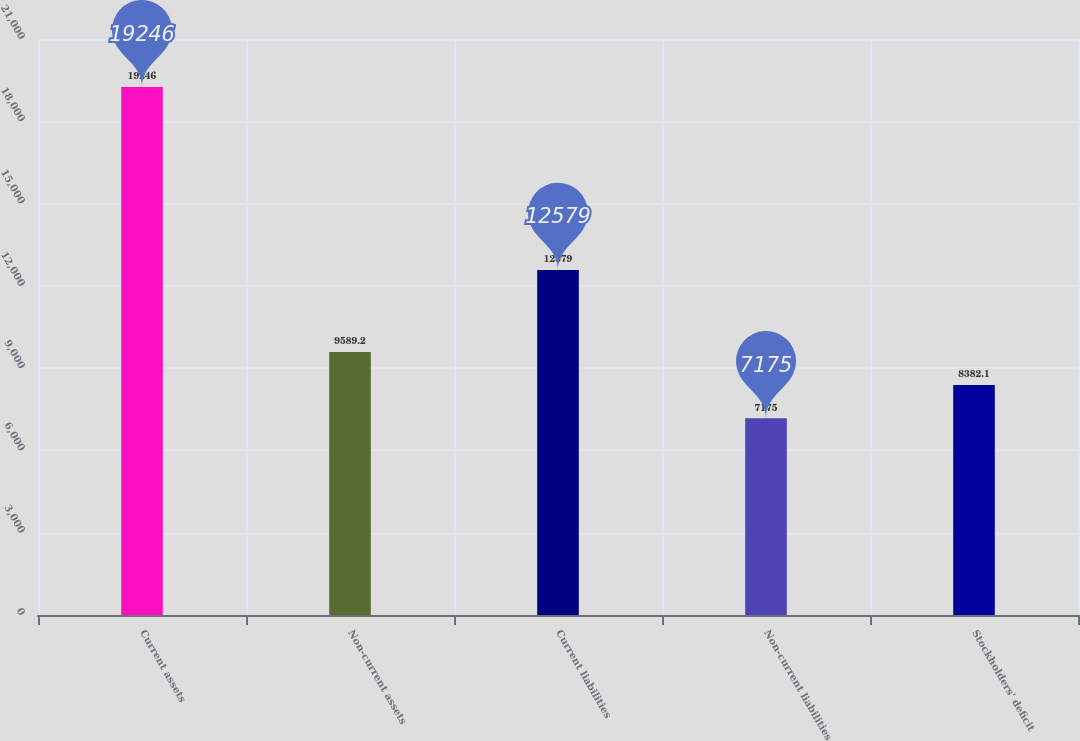<chart> <loc_0><loc_0><loc_500><loc_500><bar_chart><fcel>Current assets<fcel>Non-current assets<fcel>Current liabilities<fcel>Non-current liabilities<fcel>Stockholders' deficit<nl><fcel>19246<fcel>9589.2<fcel>12579<fcel>7175<fcel>8382.1<nl></chart> 